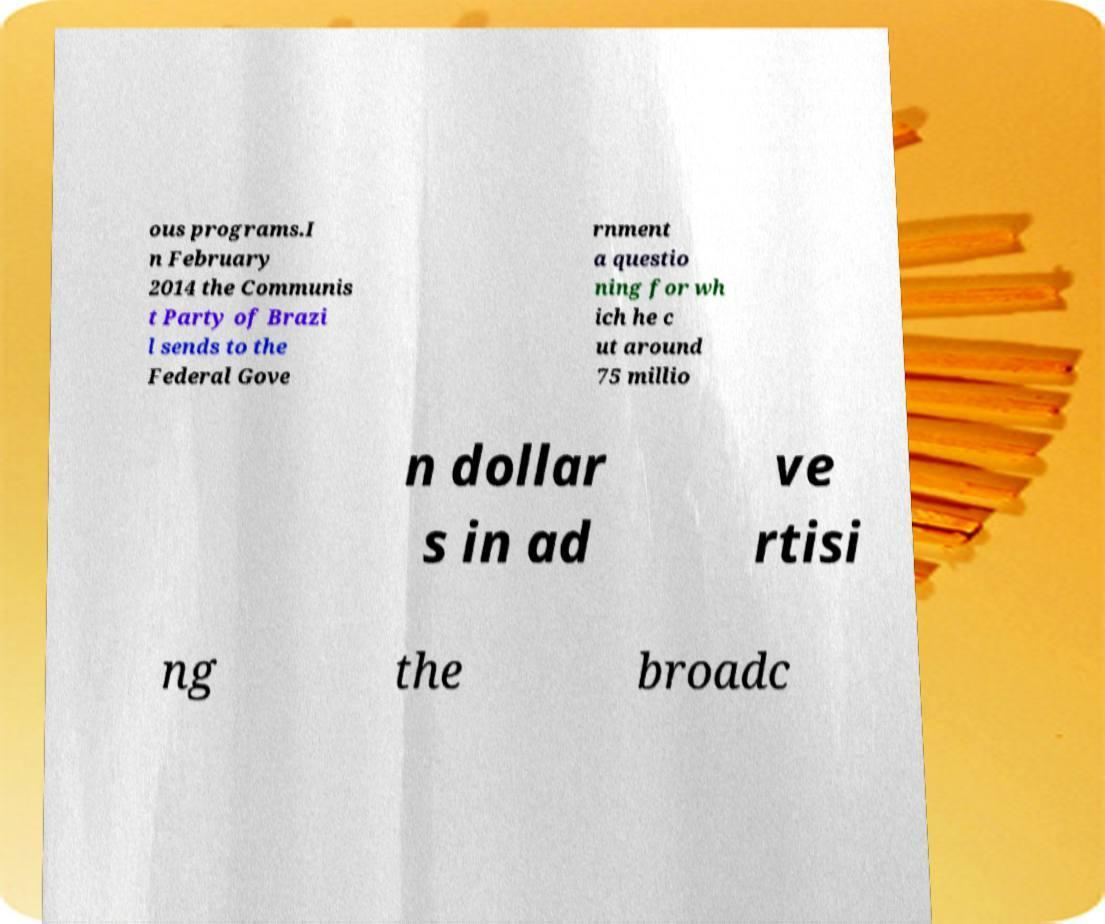Please identify and transcribe the text found in this image. ous programs.I n February 2014 the Communis t Party of Brazi l sends to the Federal Gove rnment a questio ning for wh ich he c ut around 75 millio n dollar s in ad ve rtisi ng the broadc 